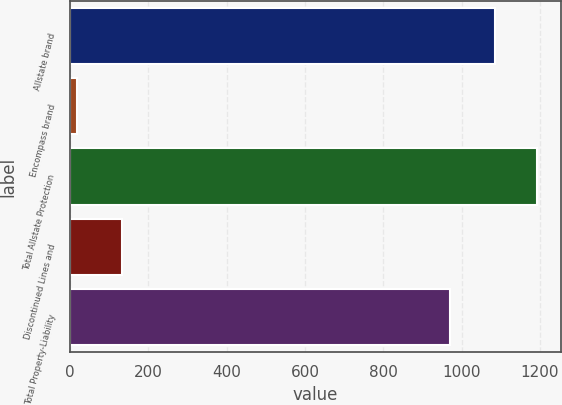Convert chart to OTSL. <chart><loc_0><loc_0><loc_500><loc_500><bar_chart><fcel>Allstate brand<fcel>Encompass brand<fcel>Total Allstate Protection<fcel>Discontinued Lines and<fcel>Total Property-Liability<nl><fcel>1085<fcel>18<fcel>1193.5<fcel>132<fcel>971<nl></chart> 